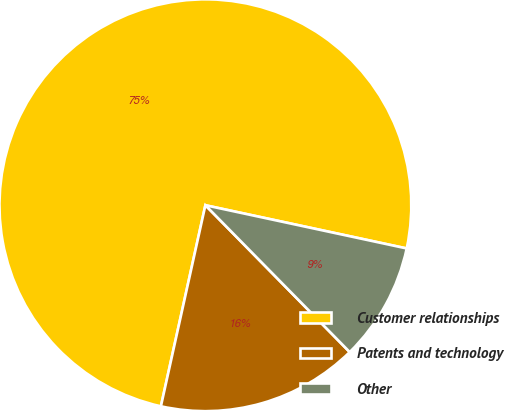Convert chart to OTSL. <chart><loc_0><loc_0><loc_500><loc_500><pie_chart><fcel>Customer relationships<fcel>Patents and technology<fcel>Other<nl><fcel>74.9%<fcel>15.83%<fcel>9.27%<nl></chart> 